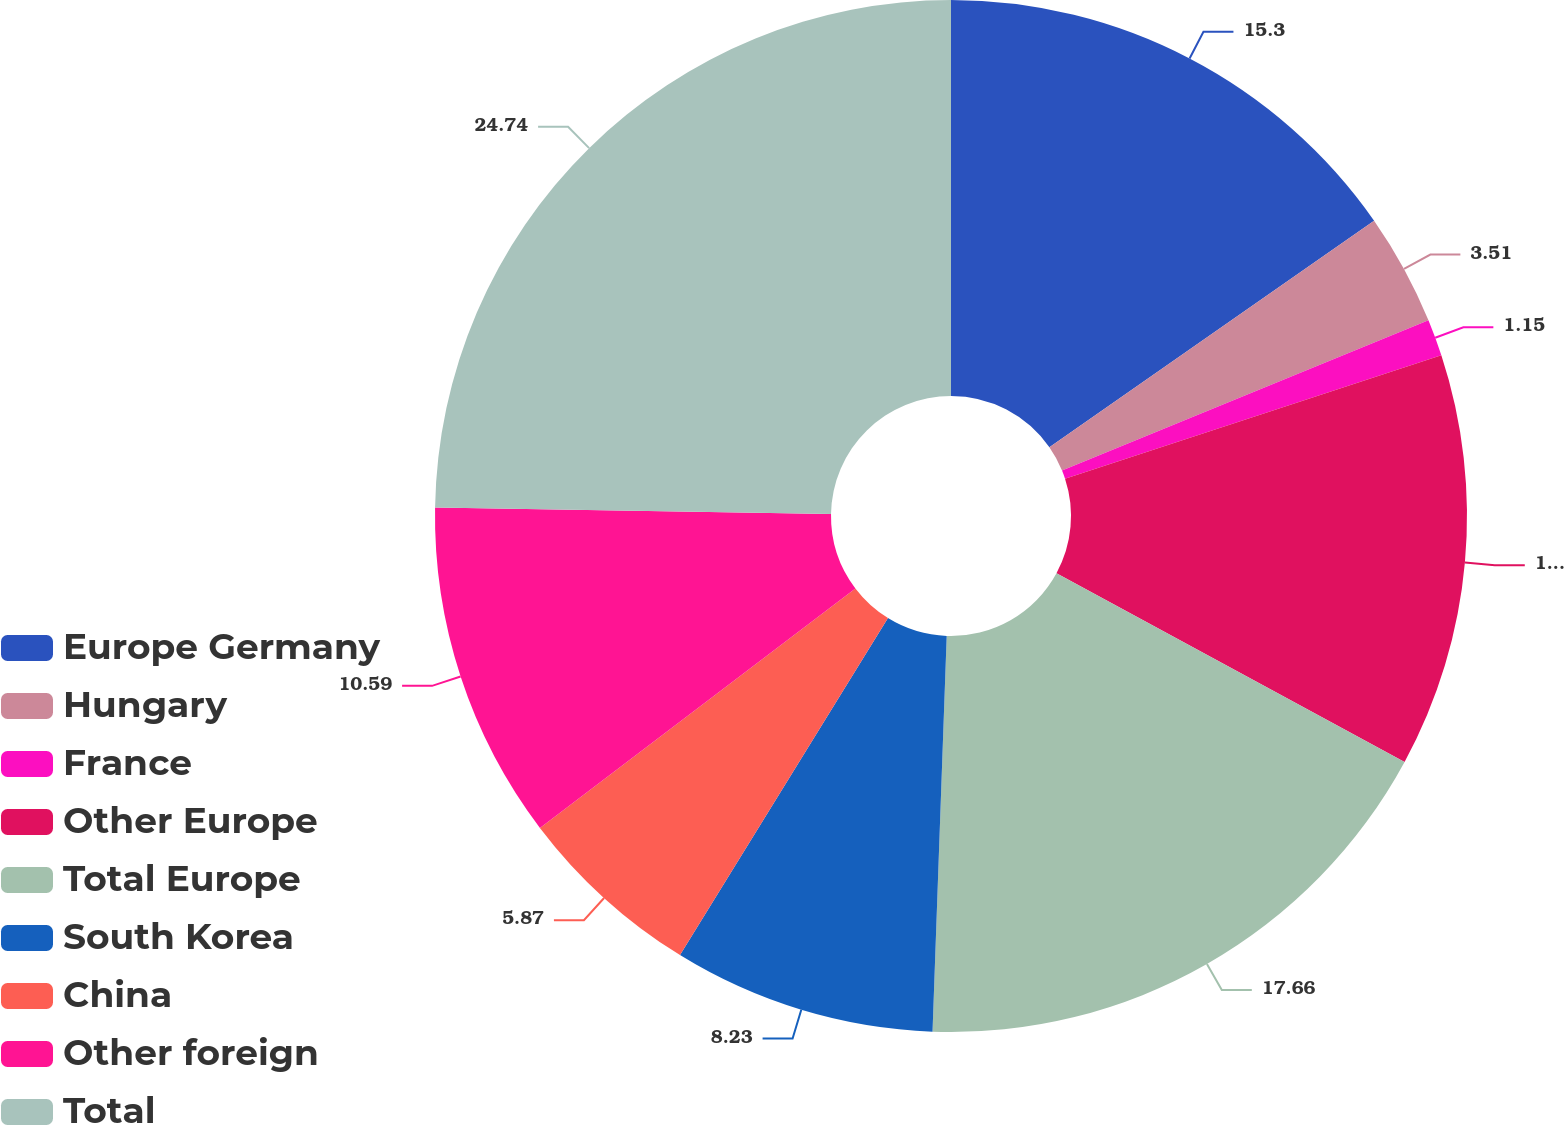<chart> <loc_0><loc_0><loc_500><loc_500><pie_chart><fcel>Europe Germany<fcel>Hungary<fcel>France<fcel>Other Europe<fcel>Total Europe<fcel>South Korea<fcel>China<fcel>Other foreign<fcel>Total<nl><fcel>15.3%<fcel>3.51%<fcel>1.15%<fcel>12.95%<fcel>17.66%<fcel>8.23%<fcel>5.87%<fcel>10.59%<fcel>24.74%<nl></chart> 